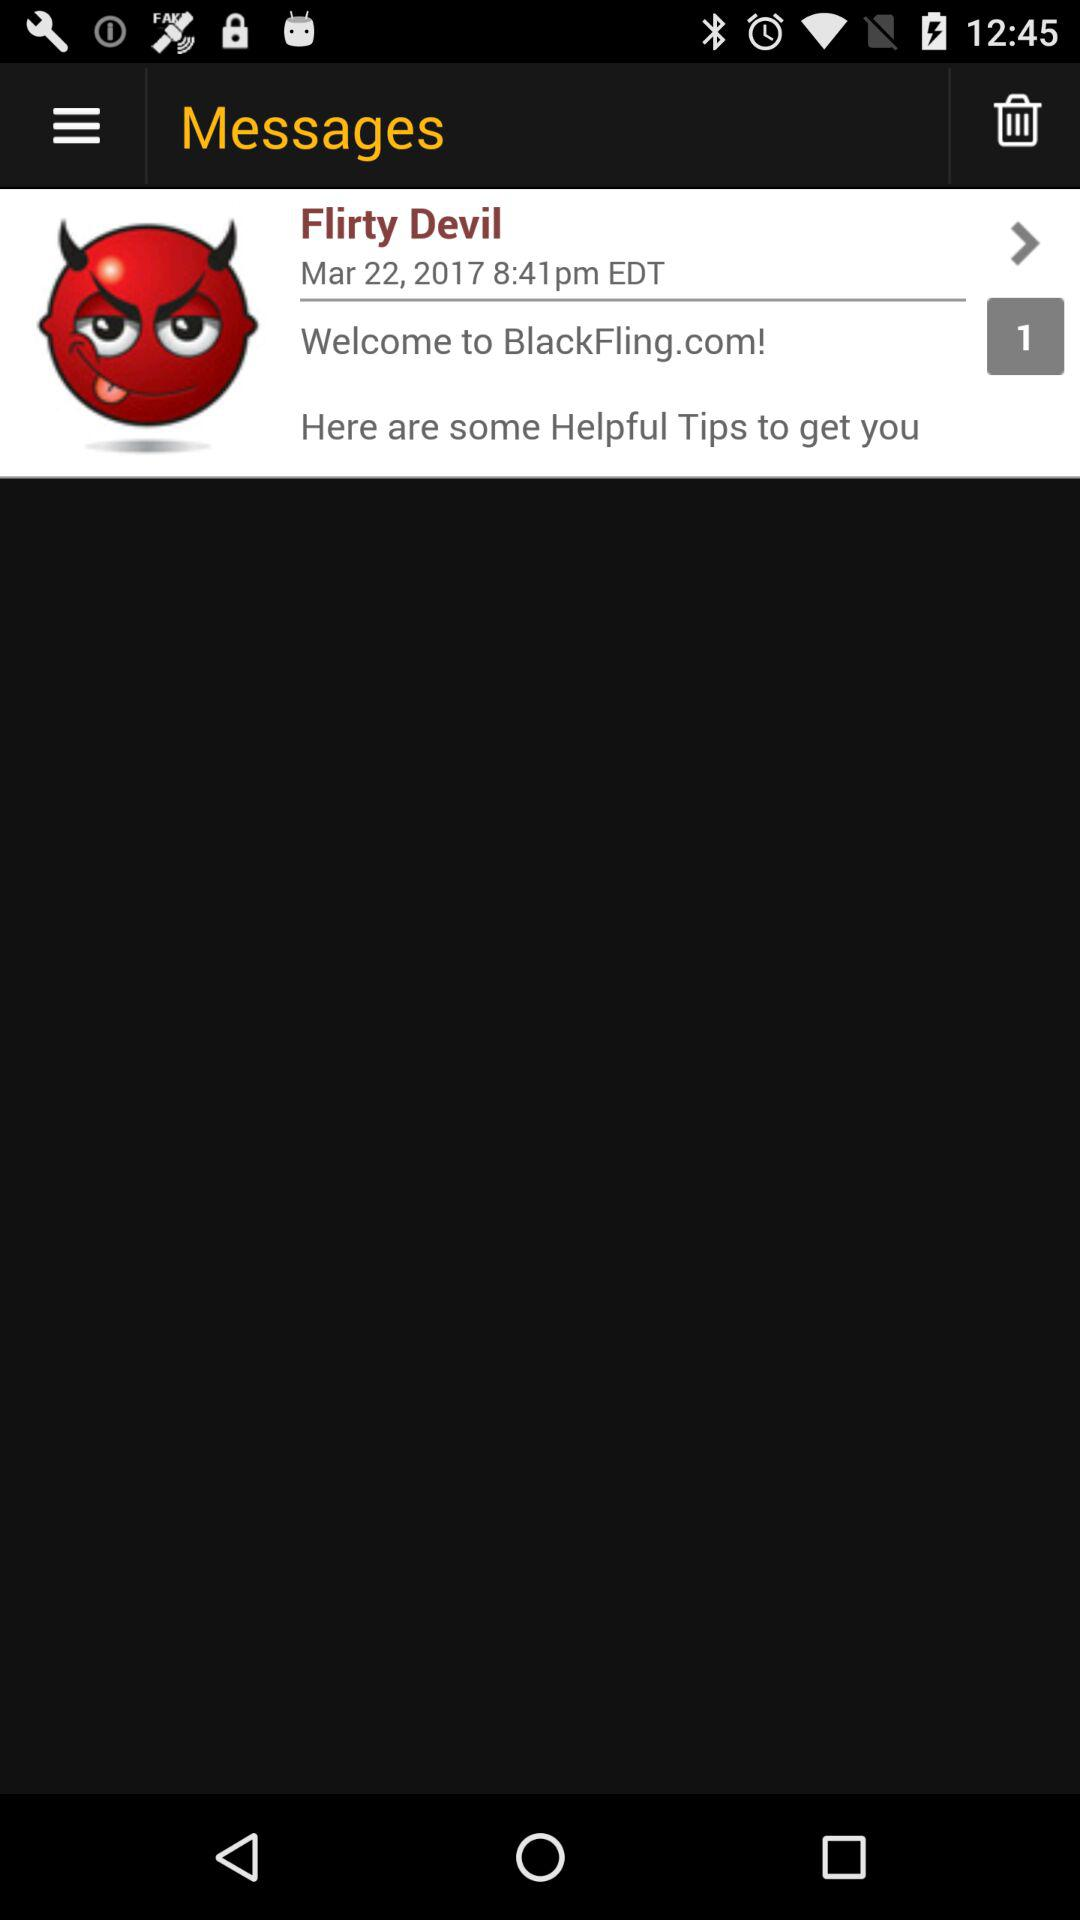On what date was the message received? The message was received on March 22, 2017. 